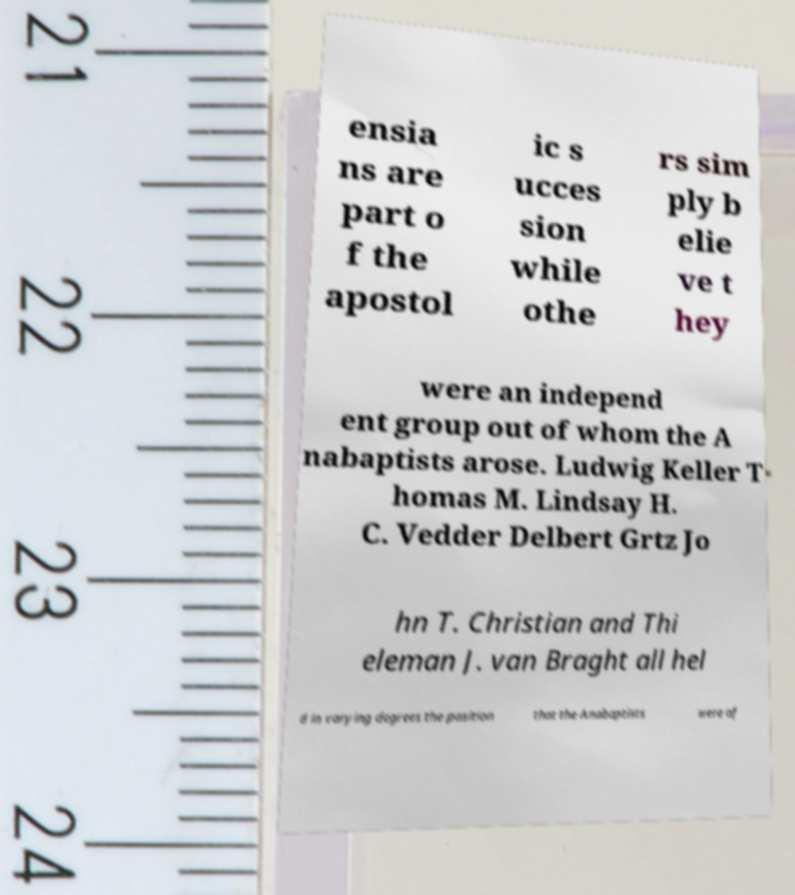There's text embedded in this image that I need extracted. Can you transcribe it verbatim? ensia ns are part o f the apostol ic s ucces sion while othe rs sim ply b elie ve t hey were an independ ent group out of whom the A nabaptists arose. Ludwig Keller T homas M. Lindsay H. C. Vedder Delbert Grtz Jo hn T. Christian and Thi eleman J. van Braght all hel d in varying degrees the position that the Anabaptists were of 